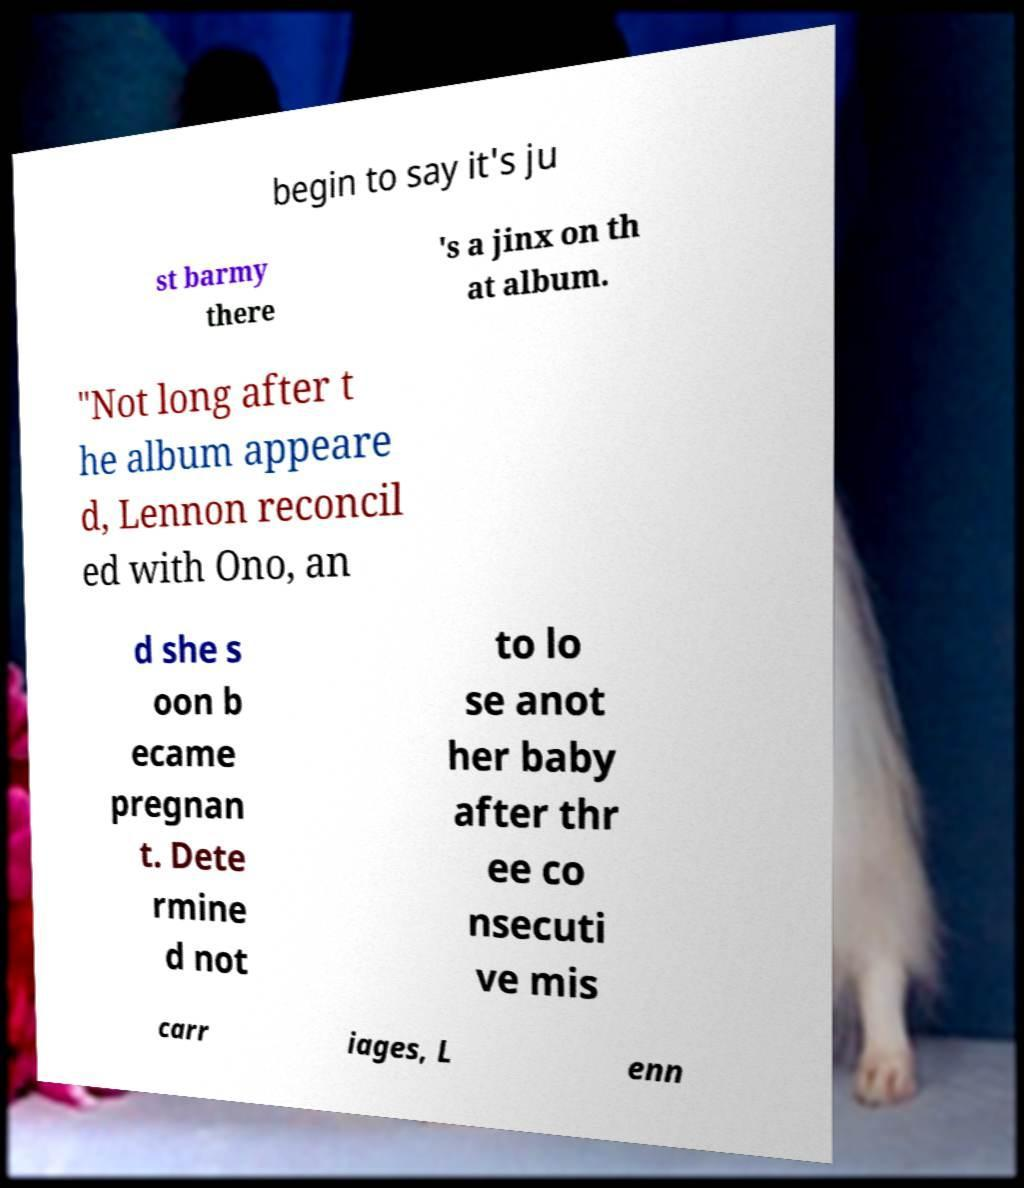I need the written content from this picture converted into text. Can you do that? begin to say it's ju st barmy there 's a jinx on th at album. "Not long after t he album appeare d, Lennon reconcil ed with Ono, an d she s oon b ecame pregnan t. Dete rmine d not to lo se anot her baby after thr ee co nsecuti ve mis carr iages, L enn 